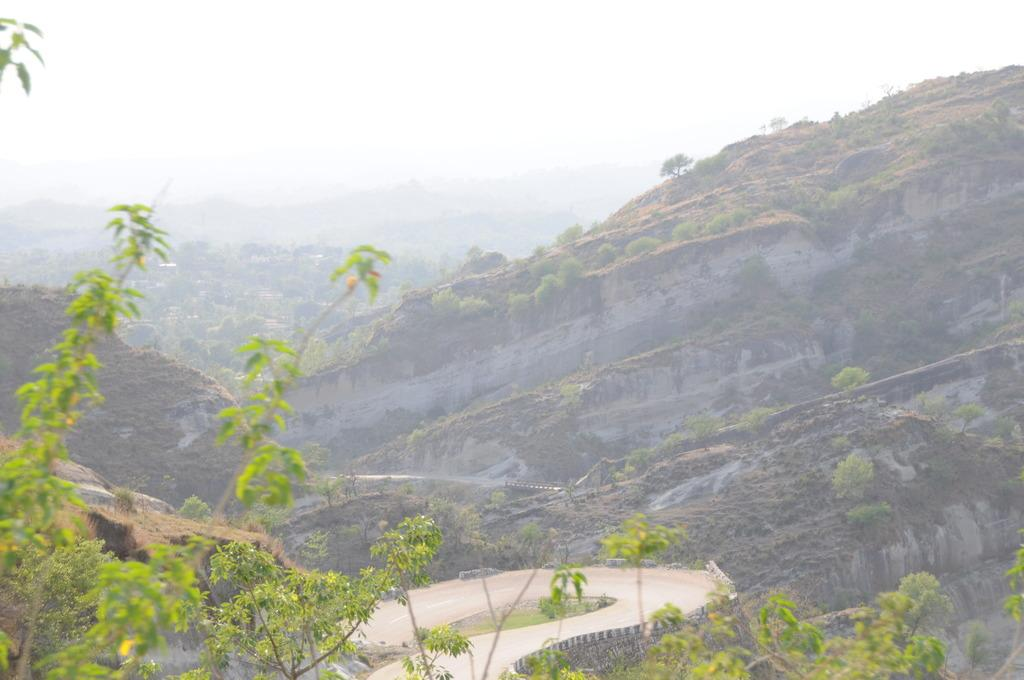What types of vegetation are present in the image? There are plants and trees in the image. What color are the plants and trees? The plants and trees are in green color. What can be seen in the background of the image? There are mountains visible in the background of the image. What is the color of the sky in the image? The sky is in white color. Can you see any ghosts interacting with the plants and trees in the image? There are no ghosts present in the image; it only features plants, trees, mountains, and the sky. What type of feather can be seen falling from the sky in the image? There is no feather visible in the image; it only features plants, trees, mountains, and the sky. 